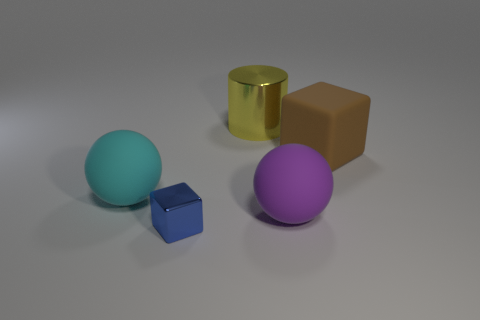There is a thing that is in front of the cyan matte sphere and to the left of the large yellow cylinder; what is its color?
Give a very brief answer. Blue. Is there a big cylinder made of the same material as the large brown thing?
Offer a terse response. No. What is the size of the blue shiny block?
Offer a terse response. Small. How big is the matte ball behind the sphere that is on the right side of the blue block?
Offer a terse response. Large. There is a large brown object that is the same shape as the blue metallic object; what is its material?
Give a very brief answer. Rubber. What number of tiny red things are there?
Keep it short and to the point. 0. What color is the large rubber sphere that is left of the shiny object that is in front of the big sphere on the left side of the large yellow metal object?
Your response must be concise. Cyan. Is the number of green rubber blocks less than the number of big cyan rubber objects?
Your answer should be compact. Yes. What color is the other matte object that is the same shape as the large purple object?
Ensure brevity in your answer.  Cyan. There is a ball that is made of the same material as the cyan object; what color is it?
Offer a very short reply. Purple. 